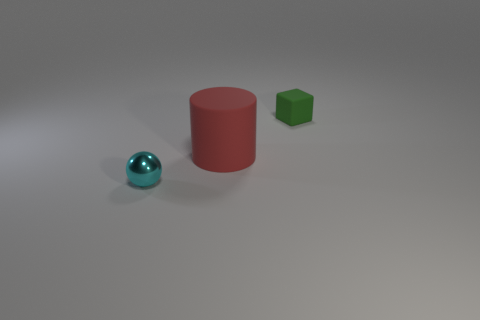How many other objects are the same size as the red matte cylinder? There are no objects that are exactly the same size as the red matte cylinder. The green cube and the blue sphere are smaller in size. 